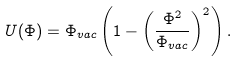<formula> <loc_0><loc_0><loc_500><loc_500>U ( \Phi ) = \Phi _ { v a c } \left ( 1 - \left ( \frac { \Phi ^ { 2 } } { \Phi _ { v a c } } \right ) ^ { 2 } \right ) .</formula> 